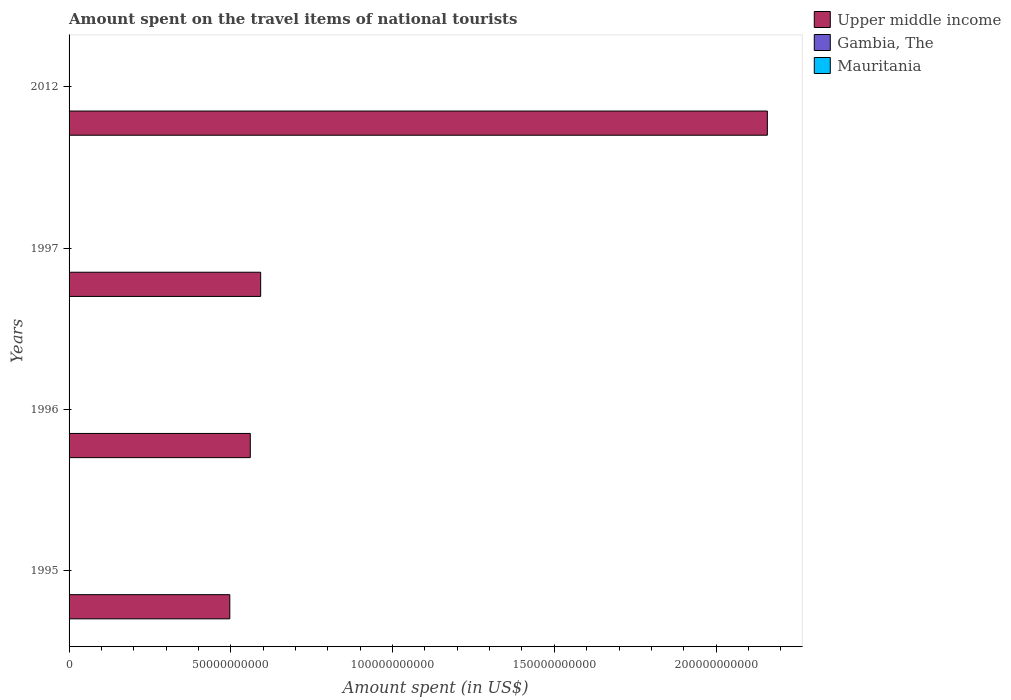How many different coloured bars are there?
Your response must be concise. 3. What is the amount spent on the travel items of national tourists in Upper middle income in 2012?
Give a very brief answer. 2.16e+11. Across all years, what is the maximum amount spent on the travel items of national tourists in Gambia, The?
Make the answer very short. 8.80e+07. Across all years, what is the minimum amount spent on the travel items of national tourists in Upper middle income?
Your answer should be very brief. 4.97e+1. What is the total amount spent on the travel items of national tourists in Mauritania in the graph?
Provide a succinct answer. 9.90e+07. What is the difference between the amount spent on the travel items of national tourists in Upper middle income in 1997 and that in 2012?
Offer a terse response. -1.57e+11. What is the difference between the amount spent on the travel items of national tourists in Mauritania in 1997 and the amount spent on the travel items of national tourists in Gambia, The in 2012?
Make the answer very short. -6.70e+07. What is the average amount spent on the travel items of national tourists in Gambia, The per year?
Provide a short and direct response. 6.42e+07. In the year 1997, what is the difference between the amount spent on the travel items of national tourists in Mauritania and amount spent on the travel items of national tourists in Gambia, The?
Your answer should be very brief. -5.40e+07. In how many years, is the amount spent on the travel items of national tourists in Gambia, The greater than 50000000000 US$?
Provide a succinct answer. 0. What is the ratio of the amount spent on the travel items of national tourists in Gambia, The in 1995 to that in 2012?
Keep it short and to the point. 0.32. Is the amount spent on the travel items of national tourists in Upper middle income in 1995 less than that in 2012?
Your answer should be compact. Yes. What is the difference between the highest and the second highest amount spent on the travel items of national tourists in Mauritania?
Your answer should be very brief. 2.70e+07. What is the difference between the highest and the lowest amount spent on the travel items of national tourists in Upper middle income?
Make the answer very short. 1.66e+11. In how many years, is the amount spent on the travel items of national tourists in Upper middle income greater than the average amount spent on the travel items of national tourists in Upper middle income taken over all years?
Keep it short and to the point. 1. Is the sum of the amount spent on the travel items of national tourists in Upper middle income in 1996 and 1997 greater than the maximum amount spent on the travel items of national tourists in Mauritania across all years?
Your answer should be very brief. Yes. What does the 3rd bar from the top in 1996 represents?
Provide a short and direct response. Upper middle income. What does the 2nd bar from the bottom in 1996 represents?
Make the answer very short. Gambia, The. Is it the case that in every year, the sum of the amount spent on the travel items of national tourists in Mauritania and amount spent on the travel items of national tourists in Gambia, The is greater than the amount spent on the travel items of national tourists in Upper middle income?
Ensure brevity in your answer.  No. Are all the bars in the graph horizontal?
Give a very brief answer. Yes. How many years are there in the graph?
Make the answer very short. 4. Are the values on the major ticks of X-axis written in scientific E-notation?
Provide a succinct answer. No. Does the graph contain grids?
Provide a short and direct response. No. Where does the legend appear in the graph?
Provide a succinct answer. Top right. What is the title of the graph?
Offer a terse response. Amount spent on the travel items of national tourists. What is the label or title of the X-axis?
Provide a short and direct response. Amount spent (in US$). What is the Amount spent (in US$) of Upper middle income in 1995?
Your answer should be very brief. 4.97e+1. What is the Amount spent (in US$) of Gambia, The in 1995?
Your answer should be very brief. 2.80e+07. What is the Amount spent (in US$) of Mauritania in 1995?
Make the answer very short. 1.10e+07. What is the Amount spent (in US$) in Upper middle income in 1996?
Provide a short and direct response. 5.60e+1. What is the Amount spent (in US$) of Gambia, The in 1996?
Provide a succinct answer. 6.60e+07. What is the Amount spent (in US$) in Mauritania in 1996?
Your answer should be compact. 1.90e+07. What is the Amount spent (in US$) of Upper middle income in 1997?
Ensure brevity in your answer.  5.92e+1. What is the Amount spent (in US$) in Gambia, The in 1997?
Your answer should be compact. 7.50e+07. What is the Amount spent (in US$) of Mauritania in 1997?
Give a very brief answer. 2.10e+07. What is the Amount spent (in US$) of Upper middle income in 2012?
Make the answer very short. 2.16e+11. What is the Amount spent (in US$) in Gambia, The in 2012?
Your answer should be very brief. 8.80e+07. What is the Amount spent (in US$) in Mauritania in 2012?
Offer a terse response. 4.80e+07. Across all years, what is the maximum Amount spent (in US$) of Upper middle income?
Provide a short and direct response. 2.16e+11. Across all years, what is the maximum Amount spent (in US$) in Gambia, The?
Make the answer very short. 8.80e+07. Across all years, what is the maximum Amount spent (in US$) in Mauritania?
Offer a very short reply. 4.80e+07. Across all years, what is the minimum Amount spent (in US$) in Upper middle income?
Your response must be concise. 4.97e+1. Across all years, what is the minimum Amount spent (in US$) of Gambia, The?
Keep it short and to the point. 2.80e+07. Across all years, what is the minimum Amount spent (in US$) of Mauritania?
Provide a short and direct response. 1.10e+07. What is the total Amount spent (in US$) of Upper middle income in the graph?
Your answer should be very brief. 3.81e+11. What is the total Amount spent (in US$) of Gambia, The in the graph?
Offer a terse response. 2.57e+08. What is the total Amount spent (in US$) of Mauritania in the graph?
Provide a succinct answer. 9.90e+07. What is the difference between the Amount spent (in US$) of Upper middle income in 1995 and that in 1996?
Give a very brief answer. -6.33e+09. What is the difference between the Amount spent (in US$) of Gambia, The in 1995 and that in 1996?
Your answer should be very brief. -3.80e+07. What is the difference between the Amount spent (in US$) in Mauritania in 1995 and that in 1996?
Keep it short and to the point. -8.00e+06. What is the difference between the Amount spent (in US$) in Upper middle income in 1995 and that in 1997?
Provide a succinct answer. -9.54e+09. What is the difference between the Amount spent (in US$) in Gambia, The in 1995 and that in 1997?
Give a very brief answer. -4.70e+07. What is the difference between the Amount spent (in US$) in Mauritania in 1995 and that in 1997?
Offer a very short reply. -1.00e+07. What is the difference between the Amount spent (in US$) in Upper middle income in 1995 and that in 2012?
Provide a succinct answer. -1.66e+11. What is the difference between the Amount spent (in US$) of Gambia, The in 1995 and that in 2012?
Your response must be concise. -6.00e+07. What is the difference between the Amount spent (in US$) in Mauritania in 1995 and that in 2012?
Ensure brevity in your answer.  -3.70e+07. What is the difference between the Amount spent (in US$) in Upper middle income in 1996 and that in 1997?
Ensure brevity in your answer.  -3.21e+09. What is the difference between the Amount spent (in US$) of Gambia, The in 1996 and that in 1997?
Your response must be concise. -9.00e+06. What is the difference between the Amount spent (in US$) in Upper middle income in 1996 and that in 2012?
Provide a succinct answer. -1.60e+11. What is the difference between the Amount spent (in US$) in Gambia, The in 1996 and that in 2012?
Offer a terse response. -2.20e+07. What is the difference between the Amount spent (in US$) in Mauritania in 1996 and that in 2012?
Your answer should be compact. -2.90e+07. What is the difference between the Amount spent (in US$) of Upper middle income in 1997 and that in 2012?
Provide a succinct answer. -1.57e+11. What is the difference between the Amount spent (in US$) of Gambia, The in 1997 and that in 2012?
Give a very brief answer. -1.30e+07. What is the difference between the Amount spent (in US$) of Mauritania in 1997 and that in 2012?
Your response must be concise. -2.70e+07. What is the difference between the Amount spent (in US$) of Upper middle income in 1995 and the Amount spent (in US$) of Gambia, The in 1996?
Make the answer very short. 4.96e+1. What is the difference between the Amount spent (in US$) of Upper middle income in 1995 and the Amount spent (in US$) of Mauritania in 1996?
Provide a short and direct response. 4.97e+1. What is the difference between the Amount spent (in US$) of Gambia, The in 1995 and the Amount spent (in US$) of Mauritania in 1996?
Your answer should be compact. 9.00e+06. What is the difference between the Amount spent (in US$) of Upper middle income in 1995 and the Amount spent (in US$) of Gambia, The in 1997?
Ensure brevity in your answer.  4.96e+1. What is the difference between the Amount spent (in US$) in Upper middle income in 1995 and the Amount spent (in US$) in Mauritania in 1997?
Provide a succinct answer. 4.97e+1. What is the difference between the Amount spent (in US$) of Gambia, The in 1995 and the Amount spent (in US$) of Mauritania in 1997?
Give a very brief answer. 7.00e+06. What is the difference between the Amount spent (in US$) in Upper middle income in 1995 and the Amount spent (in US$) in Gambia, The in 2012?
Provide a short and direct response. 4.96e+1. What is the difference between the Amount spent (in US$) of Upper middle income in 1995 and the Amount spent (in US$) of Mauritania in 2012?
Offer a terse response. 4.96e+1. What is the difference between the Amount spent (in US$) of Gambia, The in 1995 and the Amount spent (in US$) of Mauritania in 2012?
Offer a very short reply. -2.00e+07. What is the difference between the Amount spent (in US$) in Upper middle income in 1996 and the Amount spent (in US$) in Gambia, The in 1997?
Your response must be concise. 5.59e+1. What is the difference between the Amount spent (in US$) of Upper middle income in 1996 and the Amount spent (in US$) of Mauritania in 1997?
Provide a succinct answer. 5.60e+1. What is the difference between the Amount spent (in US$) in Gambia, The in 1996 and the Amount spent (in US$) in Mauritania in 1997?
Offer a very short reply. 4.50e+07. What is the difference between the Amount spent (in US$) of Upper middle income in 1996 and the Amount spent (in US$) of Gambia, The in 2012?
Your answer should be very brief. 5.59e+1. What is the difference between the Amount spent (in US$) of Upper middle income in 1996 and the Amount spent (in US$) of Mauritania in 2012?
Offer a very short reply. 5.60e+1. What is the difference between the Amount spent (in US$) in Gambia, The in 1996 and the Amount spent (in US$) in Mauritania in 2012?
Offer a terse response. 1.80e+07. What is the difference between the Amount spent (in US$) of Upper middle income in 1997 and the Amount spent (in US$) of Gambia, The in 2012?
Offer a terse response. 5.91e+1. What is the difference between the Amount spent (in US$) in Upper middle income in 1997 and the Amount spent (in US$) in Mauritania in 2012?
Provide a short and direct response. 5.92e+1. What is the difference between the Amount spent (in US$) of Gambia, The in 1997 and the Amount spent (in US$) of Mauritania in 2012?
Keep it short and to the point. 2.70e+07. What is the average Amount spent (in US$) in Upper middle income per year?
Offer a very short reply. 9.52e+1. What is the average Amount spent (in US$) of Gambia, The per year?
Your answer should be very brief. 6.42e+07. What is the average Amount spent (in US$) of Mauritania per year?
Offer a terse response. 2.48e+07. In the year 1995, what is the difference between the Amount spent (in US$) in Upper middle income and Amount spent (in US$) in Gambia, The?
Keep it short and to the point. 4.97e+1. In the year 1995, what is the difference between the Amount spent (in US$) of Upper middle income and Amount spent (in US$) of Mauritania?
Give a very brief answer. 4.97e+1. In the year 1995, what is the difference between the Amount spent (in US$) in Gambia, The and Amount spent (in US$) in Mauritania?
Offer a terse response. 1.70e+07. In the year 1996, what is the difference between the Amount spent (in US$) of Upper middle income and Amount spent (in US$) of Gambia, The?
Your answer should be very brief. 5.60e+1. In the year 1996, what is the difference between the Amount spent (in US$) of Upper middle income and Amount spent (in US$) of Mauritania?
Your answer should be very brief. 5.60e+1. In the year 1996, what is the difference between the Amount spent (in US$) of Gambia, The and Amount spent (in US$) of Mauritania?
Make the answer very short. 4.70e+07. In the year 1997, what is the difference between the Amount spent (in US$) of Upper middle income and Amount spent (in US$) of Gambia, The?
Make the answer very short. 5.91e+1. In the year 1997, what is the difference between the Amount spent (in US$) in Upper middle income and Amount spent (in US$) in Mauritania?
Your response must be concise. 5.92e+1. In the year 1997, what is the difference between the Amount spent (in US$) of Gambia, The and Amount spent (in US$) of Mauritania?
Provide a succinct answer. 5.40e+07. In the year 2012, what is the difference between the Amount spent (in US$) of Upper middle income and Amount spent (in US$) of Gambia, The?
Your answer should be very brief. 2.16e+11. In the year 2012, what is the difference between the Amount spent (in US$) of Upper middle income and Amount spent (in US$) of Mauritania?
Offer a terse response. 2.16e+11. In the year 2012, what is the difference between the Amount spent (in US$) in Gambia, The and Amount spent (in US$) in Mauritania?
Offer a terse response. 4.00e+07. What is the ratio of the Amount spent (in US$) of Upper middle income in 1995 to that in 1996?
Give a very brief answer. 0.89. What is the ratio of the Amount spent (in US$) in Gambia, The in 1995 to that in 1996?
Your response must be concise. 0.42. What is the ratio of the Amount spent (in US$) of Mauritania in 1995 to that in 1996?
Keep it short and to the point. 0.58. What is the ratio of the Amount spent (in US$) of Upper middle income in 1995 to that in 1997?
Your answer should be very brief. 0.84. What is the ratio of the Amount spent (in US$) in Gambia, The in 1995 to that in 1997?
Offer a terse response. 0.37. What is the ratio of the Amount spent (in US$) of Mauritania in 1995 to that in 1997?
Your response must be concise. 0.52. What is the ratio of the Amount spent (in US$) of Upper middle income in 1995 to that in 2012?
Your answer should be compact. 0.23. What is the ratio of the Amount spent (in US$) of Gambia, The in 1995 to that in 2012?
Your answer should be very brief. 0.32. What is the ratio of the Amount spent (in US$) in Mauritania in 1995 to that in 2012?
Your response must be concise. 0.23. What is the ratio of the Amount spent (in US$) of Upper middle income in 1996 to that in 1997?
Ensure brevity in your answer.  0.95. What is the ratio of the Amount spent (in US$) in Mauritania in 1996 to that in 1997?
Make the answer very short. 0.9. What is the ratio of the Amount spent (in US$) in Upper middle income in 1996 to that in 2012?
Ensure brevity in your answer.  0.26. What is the ratio of the Amount spent (in US$) of Gambia, The in 1996 to that in 2012?
Your answer should be compact. 0.75. What is the ratio of the Amount spent (in US$) of Mauritania in 1996 to that in 2012?
Offer a very short reply. 0.4. What is the ratio of the Amount spent (in US$) of Upper middle income in 1997 to that in 2012?
Provide a short and direct response. 0.27. What is the ratio of the Amount spent (in US$) in Gambia, The in 1997 to that in 2012?
Provide a short and direct response. 0.85. What is the ratio of the Amount spent (in US$) in Mauritania in 1997 to that in 2012?
Your response must be concise. 0.44. What is the difference between the highest and the second highest Amount spent (in US$) in Upper middle income?
Offer a terse response. 1.57e+11. What is the difference between the highest and the second highest Amount spent (in US$) in Gambia, The?
Give a very brief answer. 1.30e+07. What is the difference between the highest and the second highest Amount spent (in US$) of Mauritania?
Your answer should be very brief. 2.70e+07. What is the difference between the highest and the lowest Amount spent (in US$) in Upper middle income?
Keep it short and to the point. 1.66e+11. What is the difference between the highest and the lowest Amount spent (in US$) in Gambia, The?
Make the answer very short. 6.00e+07. What is the difference between the highest and the lowest Amount spent (in US$) of Mauritania?
Your answer should be compact. 3.70e+07. 